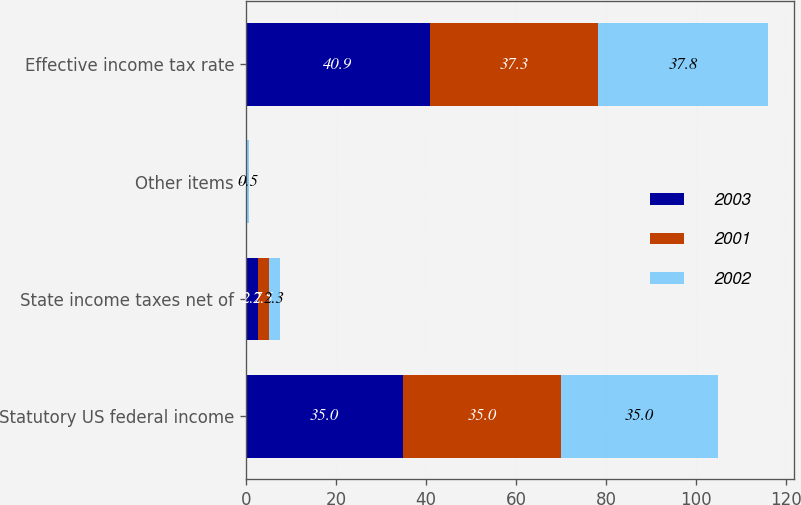<chart> <loc_0><loc_0><loc_500><loc_500><stacked_bar_chart><ecel><fcel>Statutory US federal income<fcel>State income taxes net of<fcel>Other items<fcel>Effective income tax rate<nl><fcel>2003<fcel>35<fcel>2.7<fcel>0.1<fcel>40.9<nl><fcel>2001<fcel>35<fcel>2.5<fcel>0.2<fcel>37.3<nl><fcel>2002<fcel>35<fcel>2.3<fcel>0.5<fcel>37.8<nl></chart> 